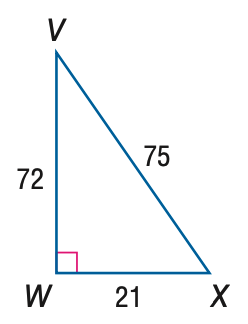Question: Express the ratio of \tan V as a decimal to the nearest hundredth.
Choices:
A. 0.28
B. 0.29
C. 0.96
D. 3.43
Answer with the letter. Answer: B Question: Express the ratio of \tan X as a decimal to the nearest hundredth.
Choices:
A. 0.28
B. 0.29
C. 0.96
D. 3.43
Answer with the letter. Answer: D 